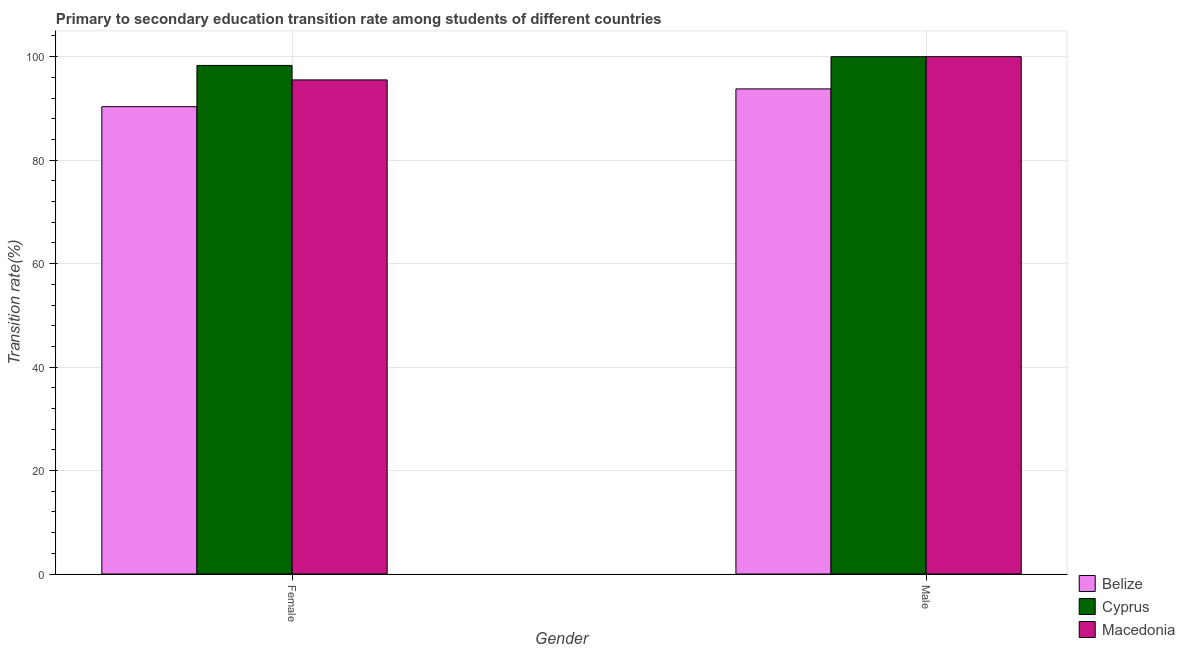How many different coloured bars are there?
Offer a terse response. 3. How many groups of bars are there?
Your response must be concise. 2. How many bars are there on the 2nd tick from the right?
Provide a short and direct response. 3. What is the transition rate among female students in Cyprus?
Make the answer very short. 98.31. Across all countries, what is the maximum transition rate among female students?
Ensure brevity in your answer.  98.31. Across all countries, what is the minimum transition rate among male students?
Your response must be concise. 93.77. In which country was the transition rate among female students maximum?
Make the answer very short. Cyprus. In which country was the transition rate among female students minimum?
Offer a terse response. Belize. What is the total transition rate among male students in the graph?
Keep it short and to the point. 293.77. What is the difference between the transition rate among male students in Belize and that in Macedonia?
Keep it short and to the point. -6.23. What is the difference between the transition rate among male students in Macedonia and the transition rate among female students in Cyprus?
Give a very brief answer. 1.69. What is the average transition rate among male students per country?
Keep it short and to the point. 97.92. What is the difference between the transition rate among female students and transition rate among male students in Belize?
Make the answer very short. -3.44. What is the ratio of the transition rate among female students in Macedonia to that in Cyprus?
Give a very brief answer. 0.97. Is the transition rate among male students in Cyprus less than that in Macedonia?
Ensure brevity in your answer.  No. In how many countries, is the transition rate among female students greater than the average transition rate among female students taken over all countries?
Your answer should be very brief. 2. What does the 3rd bar from the left in Male represents?
Your answer should be compact. Macedonia. What does the 1st bar from the right in Male represents?
Provide a succinct answer. Macedonia. How many countries are there in the graph?
Provide a short and direct response. 3. Are the values on the major ticks of Y-axis written in scientific E-notation?
Keep it short and to the point. No. Does the graph contain grids?
Provide a short and direct response. Yes. How are the legend labels stacked?
Keep it short and to the point. Vertical. What is the title of the graph?
Offer a very short reply. Primary to secondary education transition rate among students of different countries. What is the label or title of the X-axis?
Keep it short and to the point. Gender. What is the label or title of the Y-axis?
Your answer should be compact. Transition rate(%). What is the Transition rate(%) of Belize in Female?
Your answer should be compact. 90.34. What is the Transition rate(%) of Cyprus in Female?
Provide a short and direct response. 98.31. What is the Transition rate(%) of Macedonia in Female?
Give a very brief answer. 95.51. What is the Transition rate(%) in Belize in Male?
Offer a very short reply. 93.77. What is the Transition rate(%) of Cyprus in Male?
Keep it short and to the point. 100. What is the Transition rate(%) of Macedonia in Male?
Give a very brief answer. 100. Across all Gender, what is the maximum Transition rate(%) of Belize?
Offer a very short reply. 93.77. Across all Gender, what is the maximum Transition rate(%) in Cyprus?
Offer a terse response. 100. Across all Gender, what is the minimum Transition rate(%) of Belize?
Provide a short and direct response. 90.34. Across all Gender, what is the minimum Transition rate(%) in Cyprus?
Provide a short and direct response. 98.31. Across all Gender, what is the minimum Transition rate(%) of Macedonia?
Your answer should be compact. 95.51. What is the total Transition rate(%) of Belize in the graph?
Make the answer very short. 184.11. What is the total Transition rate(%) in Cyprus in the graph?
Provide a succinct answer. 198.31. What is the total Transition rate(%) of Macedonia in the graph?
Offer a very short reply. 195.51. What is the difference between the Transition rate(%) in Belize in Female and that in Male?
Give a very brief answer. -3.44. What is the difference between the Transition rate(%) in Cyprus in Female and that in Male?
Provide a short and direct response. -1.69. What is the difference between the Transition rate(%) in Macedonia in Female and that in Male?
Keep it short and to the point. -4.49. What is the difference between the Transition rate(%) in Belize in Female and the Transition rate(%) in Cyprus in Male?
Provide a succinct answer. -9.66. What is the difference between the Transition rate(%) in Belize in Female and the Transition rate(%) in Macedonia in Male?
Make the answer very short. -9.66. What is the difference between the Transition rate(%) in Cyprus in Female and the Transition rate(%) in Macedonia in Male?
Provide a succinct answer. -1.69. What is the average Transition rate(%) in Belize per Gender?
Give a very brief answer. 92.06. What is the average Transition rate(%) of Cyprus per Gender?
Ensure brevity in your answer.  99.16. What is the average Transition rate(%) of Macedonia per Gender?
Make the answer very short. 97.76. What is the difference between the Transition rate(%) in Belize and Transition rate(%) in Cyprus in Female?
Your answer should be very brief. -7.97. What is the difference between the Transition rate(%) of Belize and Transition rate(%) of Macedonia in Female?
Your answer should be compact. -5.17. What is the difference between the Transition rate(%) of Cyprus and Transition rate(%) of Macedonia in Female?
Give a very brief answer. 2.8. What is the difference between the Transition rate(%) of Belize and Transition rate(%) of Cyprus in Male?
Offer a terse response. -6.23. What is the difference between the Transition rate(%) of Belize and Transition rate(%) of Macedonia in Male?
Provide a short and direct response. -6.23. What is the ratio of the Transition rate(%) in Belize in Female to that in Male?
Make the answer very short. 0.96. What is the ratio of the Transition rate(%) of Cyprus in Female to that in Male?
Keep it short and to the point. 0.98. What is the ratio of the Transition rate(%) in Macedonia in Female to that in Male?
Provide a succinct answer. 0.96. What is the difference between the highest and the second highest Transition rate(%) of Belize?
Keep it short and to the point. 3.44. What is the difference between the highest and the second highest Transition rate(%) in Cyprus?
Offer a very short reply. 1.69. What is the difference between the highest and the second highest Transition rate(%) of Macedonia?
Provide a short and direct response. 4.49. What is the difference between the highest and the lowest Transition rate(%) in Belize?
Your answer should be very brief. 3.44. What is the difference between the highest and the lowest Transition rate(%) in Cyprus?
Make the answer very short. 1.69. What is the difference between the highest and the lowest Transition rate(%) of Macedonia?
Your response must be concise. 4.49. 